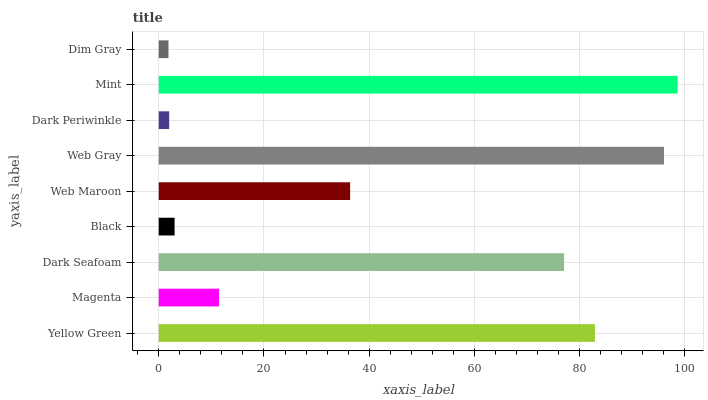Is Dim Gray the minimum?
Answer yes or no. Yes. Is Mint the maximum?
Answer yes or no. Yes. Is Magenta the minimum?
Answer yes or no. No. Is Magenta the maximum?
Answer yes or no. No. Is Yellow Green greater than Magenta?
Answer yes or no. Yes. Is Magenta less than Yellow Green?
Answer yes or no. Yes. Is Magenta greater than Yellow Green?
Answer yes or no. No. Is Yellow Green less than Magenta?
Answer yes or no. No. Is Web Maroon the high median?
Answer yes or no. Yes. Is Web Maroon the low median?
Answer yes or no. Yes. Is Magenta the high median?
Answer yes or no. No. Is Web Gray the low median?
Answer yes or no. No. 